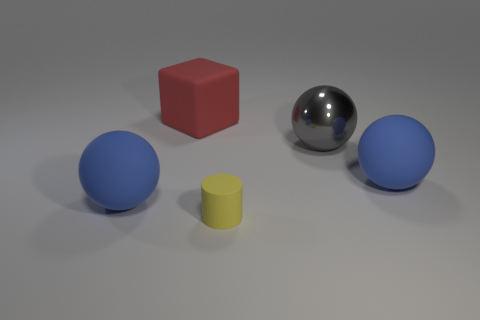Add 4 yellow rubber things. How many objects exist? 9 Subtract all blocks. How many objects are left? 4 Add 1 big red blocks. How many big red blocks are left? 2 Add 2 matte blocks. How many matte blocks exist? 3 Subtract 0 gray blocks. How many objects are left? 5 Subtract all big cyan metallic things. Subtract all big metallic objects. How many objects are left? 4 